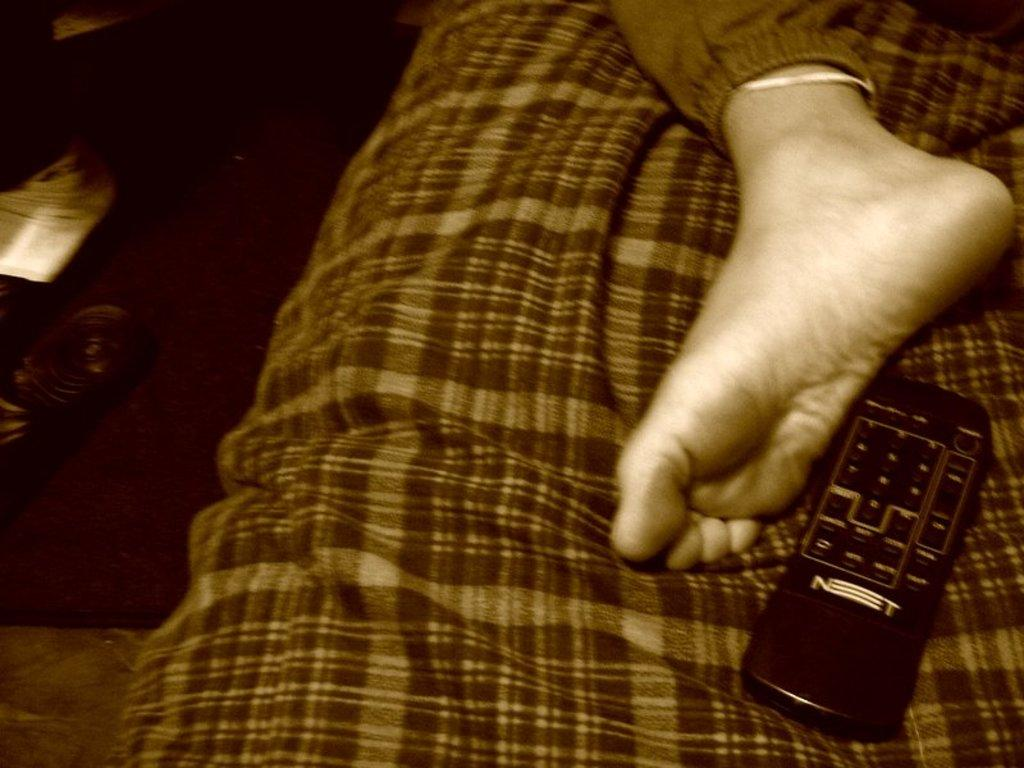<image>
Create a compact narrative representing the image presented. A man's foot is visible lying on a bed next to a remote control with the letters N and T on it. 